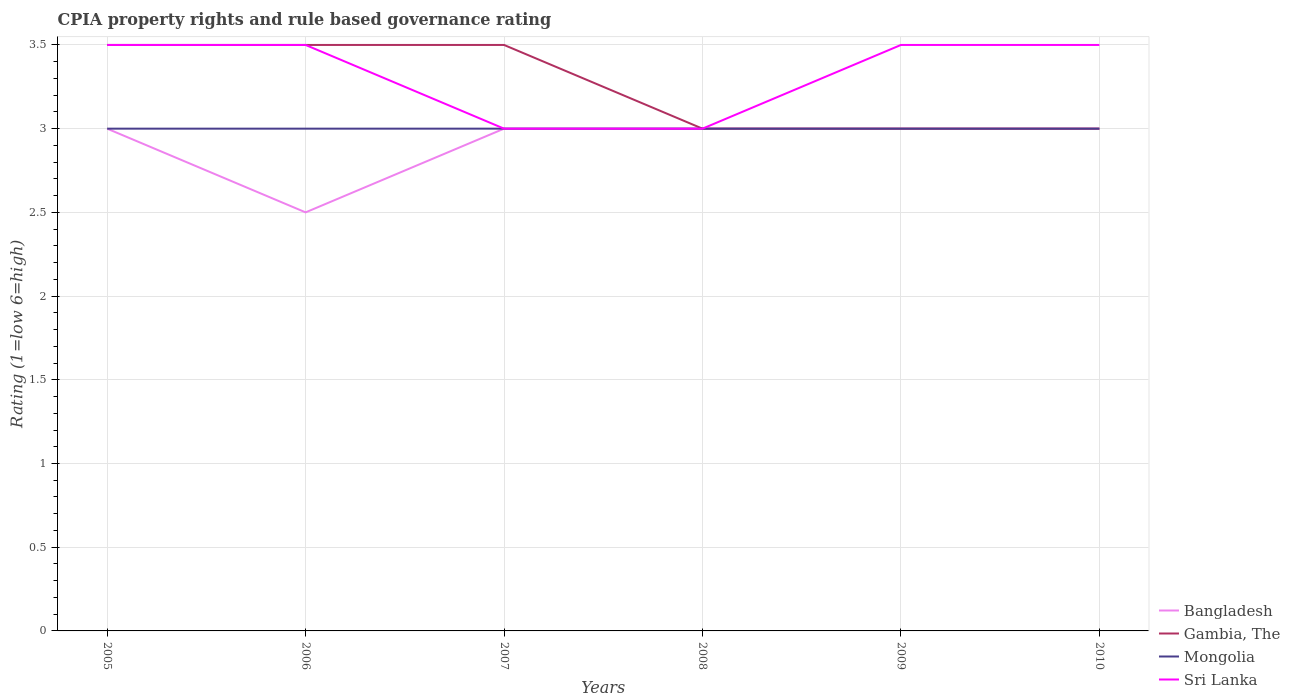Does the line corresponding to Bangladesh intersect with the line corresponding to Mongolia?
Your response must be concise. Yes. Is the number of lines equal to the number of legend labels?
Offer a very short reply. Yes. What is the difference between the highest and the lowest CPIA rating in Mongolia?
Make the answer very short. 0. How many lines are there?
Your response must be concise. 4. How many years are there in the graph?
Offer a terse response. 6. What is the difference between two consecutive major ticks on the Y-axis?
Offer a very short reply. 0.5. Are the values on the major ticks of Y-axis written in scientific E-notation?
Make the answer very short. No. Does the graph contain grids?
Offer a very short reply. Yes. Where does the legend appear in the graph?
Ensure brevity in your answer.  Bottom right. What is the title of the graph?
Your response must be concise. CPIA property rights and rule based governance rating. What is the label or title of the X-axis?
Ensure brevity in your answer.  Years. What is the Rating (1=low 6=high) of Bangladesh in 2006?
Give a very brief answer. 2.5. What is the Rating (1=low 6=high) of Sri Lanka in 2006?
Make the answer very short. 3.5. What is the Rating (1=low 6=high) in Mongolia in 2007?
Provide a succinct answer. 3. What is the Rating (1=low 6=high) of Gambia, The in 2008?
Your answer should be compact. 3. What is the Rating (1=low 6=high) of Mongolia in 2008?
Your answer should be compact. 3. What is the Rating (1=low 6=high) of Sri Lanka in 2008?
Make the answer very short. 3. What is the Rating (1=low 6=high) of Gambia, The in 2009?
Provide a short and direct response. 3. What is the Rating (1=low 6=high) in Mongolia in 2009?
Provide a succinct answer. 3. What is the Rating (1=low 6=high) of Sri Lanka in 2009?
Give a very brief answer. 3.5. What is the Rating (1=low 6=high) in Bangladesh in 2010?
Your answer should be very brief. 3. What is the Rating (1=low 6=high) of Mongolia in 2010?
Offer a very short reply. 3. Across all years, what is the maximum Rating (1=low 6=high) of Sri Lanka?
Your answer should be compact. 3.5. Across all years, what is the minimum Rating (1=low 6=high) of Bangladesh?
Ensure brevity in your answer.  2.5. Across all years, what is the minimum Rating (1=low 6=high) of Gambia, The?
Keep it short and to the point. 3. What is the difference between the Rating (1=low 6=high) of Gambia, The in 2005 and that in 2006?
Offer a terse response. 0. What is the difference between the Rating (1=low 6=high) in Sri Lanka in 2005 and that in 2006?
Provide a short and direct response. 0. What is the difference between the Rating (1=low 6=high) in Bangladesh in 2005 and that in 2007?
Ensure brevity in your answer.  0. What is the difference between the Rating (1=low 6=high) of Mongolia in 2005 and that in 2008?
Your response must be concise. 0. What is the difference between the Rating (1=low 6=high) of Gambia, The in 2005 and that in 2009?
Your answer should be very brief. 0.5. What is the difference between the Rating (1=low 6=high) of Mongolia in 2005 and that in 2009?
Offer a terse response. 0. What is the difference between the Rating (1=low 6=high) of Bangladesh in 2005 and that in 2010?
Offer a terse response. 0. What is the difference between the Rating (1=low 6=high) of Gambia, The in 2005 and that in 2010?
Your response must be concise. 0.5. What is the difference between the Rating (1=low 6=high) of Mongolia in 2005 and that in 2010?
Keep it short and to the point. 0. What is the difference between the Rating (1=low 6=high) of Bangladesh in 2006 and that in 2007?
Give a very brief answer. -0.5. What is the difference between the Rating (1=low 6=high) in Gambia, The in 2006 and that in 2007?
Offer a terse response. 0. What is the difference between the Rating (1=low 6=high) in Mongolia in 2006 and that in 2007?
Offer a terse response. 0. What is the difference between the Rating (1=low 6=high) in Gambia, The in 2006 and that in 2009?
Give a very brief answer. 0.5. What is the difference between the Rating (1=low 6=high) of Mongolia in 2006 and that in 2009?
Your answer should be very brief. 0. What is the difference between the Rating (1=low 6=high) of Sri Lanka in 2006 and that in 2009?
Give a very brief answer. 0. What is the difference between the Rating (1=low 6=high) of Sri Lanka in 2006 and that in 2010?
Your answer should be compact. 0. What is the difference between the Rating (1=low 6=high) of Bangladesh in 2007 and that in 2008?
Your answer should be compact. 0. What is the difference between the Rating (1=low 6=high) in Gambia, The in 2007 and that in 2008?
Give a very brief answer. 0.5. What is the difference between the Rating (1=low 6=high) of Mongolia in 2007 and that in 2008?
Provide a short and direct response. 0. What is the difference between the Rating (1=low 6=high) in Sri Lanka in 2007 and that in 2008?
Your response must be concise. 0. What is the difference between the Rating (1=low 6=high) in Mongolia in 2007 and that in 2010?
Your answer should be very brief. 0. What is the difference between the Rating (1=low 6=high) of Bangladesh in 2008 and that in 2009?
Keep it short and to the point. 0. What is the difference between the Rating (1=low 6=high) of Gambia, The in 2008 and that in 2009?
Keep it short and to the point. 0. What is the difference between the Rating (1=low 6=high) in Sri Lanka in 2008 and that in 2009?
Provide a succinct answer. -0.5. What is the difference between the Rating (1=low 6=high) of Mongolia in 2008 and that in 2010?
Provide a succinct answer. 0. What is the difference between the Rating (1=low 6=high) of Bangladesh in 2005 and the Rating (1=low 6=high) of Mongolia in 2006?
Ensure brevity in your answer.  0. What is the difference between the Rating (1=low 6=high) in Bangladesh in 2005 and the Rating (1=low 6=high) in Sri Lanka in 2006?
Provide a succinct answer. -0.5. What is the difference between the Rating (1=low 6=high) in Gambia, The in 2005 and the Rating (1=low 6=high) in Sri Lanka in 2006?
Your response must be concise. 0. What is the difference between the Rating (1=low 6=high) of Mongolia in 2005 and the Rating (1=low 6=high) of Sri Lanka in 2006?
Your answer should be compact. -0.5. What is the difference between the Rating (1=low 6=high) of Bangladesh in 2005 and the Rating (1=low 6=high) of Gambia, The in 2007?
Make the answer very short. -0.5. What is the difference between the Rating (1=low 6=high) in Bangladesh in 2005 and the Rating (1=low 6=high) in Mongolia in 2007?
Provide a short and direct response. 0. What is the difference between the Rating (1=low 6=high) of Bangladesh in 2005 and the Rating (1=low 6=high) of Sri Lanka in 2007?
Your answer should be very brief. 0. What is the difference between the Rating (1=low 6=high) of Gambia, The in 2005 and the Rating (1=low 6=high) of Sri Lanka in 2007?
Your answer should be compact. 0.5. What is the difference between the Rating (1=low 6=high) of Bangladesh in 2005 and the Rating (1=low 6=high) of Sri Lanka in 2008?
Provide a short and direct response. 0. What is the difference between the Rating (1=low 6=high) of Gambia, The in 2005 and the Rating (1=low 6=high) of Sri Lanka in 2008?
Provide a succinct answer. 0.5. What is the difference between the Rating (1=low 6=high) of Bangladesh in 2005 and the Rating (1=low 6=high) of Gambia, The in 2009?
Your response must be concise. 0. What is the difference between the Rating (1=low 6=high) in Bangladesh in 2005 and the Rating (1=low 6=high) in Sri Lanka in 2009?
Provide a succinct answer. -0.5. What is the difference between the Rating (1=low 6=high) in Gambia, The in 2005 and the Rating (1=low 6=high) in Mongolia in 2009?
Ensure brevity in your answer.  0.5. What is the difference between the Rating (1=low 6=high) in Bangladesh in 2005 and the Rating (1=low 6=high) in Sri Lanka in 2010?
Offer a very short reply. -0.5. What is the difference between the Rating (1=low 6=high) of Gambia, The in 2005 and the Rating (1=low 6=high) of Sri Lanka in 2010?
Provide a succinct answer. 0. What is the difference between the Rating (1=low 6=high) in Mongolia in 2005 and the Rating (1=low 6=high) in Sri Lanka in 2010?
Your answer should be compact. -0.5. What is the difference between the Rating (1=low 6=high) in Bangladesh in 2006 and the Rating (1=low 6=high) in Sri Lanka in 2007?
Your answer should be very brief. -0.5. What is the difference between the Rating (1=low 6=high) of Gambia, The in 2006 and the Rating (1=low 6=high) of Sri Lanka in 2007?
Offer a terse response. 0.5. What is the difference between the Rating (1=low 6=high) of Bangladesh in 2006 and the Rating (1=low 6=high) of Gambia, The in 2008?
Make the answer very short. -0.5. What is the difference between the Rating (1=low 6=high) in Bangladesh in 2006 and the Rating (1=low 6=high) in Sri Lanka in 2008?
Your answer should be compact. -0.5. What is the difference between the Rating (1=low 6=high) of Gambia, The in 2006 and the Rating (1=low 6=high) of Sri Lanka in 2008?
Keep it short and to the point. 0.5. What is the difference between the Rating (1=low 6=high) of Gambia, The in 2006 and the Rating (1=low 6=high) of Sri Lanka in 2009?
Offer a very short reply. 0. What is the difference between the Rating (1=low 6=high) of Mongolia in 2006 and the Rating (1=low 6=high) of Sri Lanka in 2009?
Ensure brevity in your answer.  -0.5. What is the difference between the Rating (1=low 6=high) in Bangladesh in 2006 and the Rating (1=low 6=high) in Gambia, The in 2010?
Make the answer very short. -0.5. What is the difference between the Rating (1=low 6=high) in Bangladesh in 2006 and the Rating (1=low 6=high) in Mongolia in 2010?
Your response must be concise. -0.5. What is the difference between the Rating (1=low 6=high) in Gambia, The in 2006 and the Rating (1=low 6=high) in Mongolia in 2010?
Ensure brevity in your answer.  0.5. What is the difference between the Rating (1=low 6=high) of Mongolia in 2006 and the Rating (1=low 6=high) of Sri Lanka in 2010?
Ensure brevity in your answer.  -0.5. What is the difference between the Rating (1=low 6=high) in Bangladesh in 2007 and the Rating (1=low 6=high) in Mongolia in 2008?
Make the answer very short. 0. What is the difference between the Rating (1=low 6=high) of Gambia, The in 2007 and the Rating (1=low 6=high) of Mongolia in 2008?
Offer a terse response. 0.5. What is the difference between the Rating (1=low 6=high) in Mongolia in 2007 and the Rating (1=low 6=high) in Sri Lanka in 2008?
Ensure brevity in your answer.  0. What is the difference between the Rating (1=low 6=high) of Bangladesh in 2007 and the Rating (1=low 6=high) of Gambia, The in 2009?
Keep it short and to the point. 0. What is the difference between the Rating (1=low 6=high) in Bangladesh in 2007 and the Rating (1=low 6=high) in Sri Lanka in 2009?
Give a very brief answer. -0.5. What is the difference between the Rating (1=low 6=high) in Gambia, The in 2007 and the Rating (1=low 6=high) in Mongolia in 2009?
Keep it short and to the point. 0.5. What is the difference between the Rating (1=low 6=high) in Bangladesh in 2007 and the Rating (1=low 6=high) in Sri Lanka in 2010?
Your response must be concise. -0.5. What is the difference between the Rating (1=low 6=high) of Gambia, The in 2008 and the Rating (1=low 6=high) of Mongolia in 2009?
Provide a succinct answer. 0. What is the difference between the Rating (1=low 6=high) of Bangladesh in 2008 and the Rating (1=low 6=high) of Gambia, The in 2010?
Keep it short and to the point. 0. What is the difference between the Rating (1=low 6=high) in Gambia, The in 2008 and the Rating (1=low 6=high) in Sri Lanka in 2010?
Your response must be concise. -0.5. What is the difference between the Rating (1=low 6=high) in Bangladesh in 2009 and the Rating (1=low 6=high) in Gambia, The in 2010?
Provide a succinct answer. 0. What is the difference between the Rating (1=low 6=high) in Bangladesh in 2009 and the Rating (1=low 6=high) in Mongolia in 2010?
Your answer should be compact. 0. What is the difference between the Rating (1=low 6=high) in Bangladesh in 2009 and the Rating (1=low 6=high) in Sri Lanka in 2010?
Make the answer very short. -0.5. What is the difference between the Rating (1=low 6=high) in Gambia, The in 2009 and the Rating (1=low 6=high) in Mongolia in 2010?
Provide a short and direct response. 0. What is the difference between the Rating (1=low 6=high) of Gambia, The in 2009 and the Rating (1=low 6=high) of Sri Lanka in 2010?
Provide a short and direct response. -0.5. What is the average Rating (1=low 6=high) in Bangladesh per year?
Your answer should be compact. 2.92. What is the average Rating (1=low 6=high) in Gambia, The per year?
Keep it short and to the point. 3.25. In the year 2005, what is the difference between the Rating (1=low 6=high) of Bangladesh and Rating (1=low 6=high) of Mongolia?
Provide a short and direct response. 0. In the year 2005, what is the difference between the Rating (1=low 6=high) of Gambia, The and Rating (1=low 6=high) of Mongolia?
Provide a short and direct response. 0.5. In the year 2005, what is the difference between the Rating (1=low 6=high) of Gambia, The and Rating (1=low 6=high) of Sri Lanka?
Provide a short and direct response. 0. In the year 2006, what is the difference between the Rating (1=low 6=high) of Bangladesh and Rating (1=low 6=high) of Gambia, The?
Provide a short and direct response. -1. In the year 2006, what is the difference between the Rating (1=low 6=high) of Bangladesh and Rating (1=low 6=high) of Sri Lanka?
Provide a succinct answer. -1. In the year 2006, what is the difference between the Rating (1=low 6=high) in Gambia, The and Rating (1=low 6=high) in Mongolia?
Make the answer very short. 0.5. In the year 2006, what is the difference between the Rating (1=low 6=high) in Gambia, The and Rating (1=low 6=high) in Sri Lanka?
Your answer should be very brief. 0. In the year 2007, what is the difference between the Rating (1=low 6=high) of Bangladesh and Rating (1=low 6=high) of Mongolia?
Provide a short and direct response. 0. In the year 2007, what is the difference between the Rating (1=low 6=high) in Bangladesh and Rating (1=low 6=high) in Sri Lanka?
Ensure brevity in your answer.  0. In the year 2007, what is the difference between the Rating (1=low 6=high) of Gambia, The and Rating (1=low 6=high) of Mongolia?
Give a very brief answer. 0.5. In the year 2008, what is the difference between the Rating (1=low 6=high) of Bangladesh and Rating (1=low 6=high) of Sri Lanka?
Offer a very short reply. 0. In the year 2008, what is the difference between the Rating (1=low 6=high) of Gambia, The and Rating (1=low 6=high) of Mongolia?
Offer a terse response. 0. In the year 2008, what is the difference between the Rating (1=low 6=high) in Mongolia and Rating (1=low 6=high) in Sri Lanka?
Ensure brevity in your answer.  0. In the year 2009, what is the difference between the Rating (1=low 6=high) in Bangladesh and Rating (1=low 6=high) in Gambia, The?
Provide a short and direct response. 0. In the year 2010, what is the difference between the Rating (1=low 6=high) of Gambia, The and Rating (1=low 6=high) of Mongolia?
Keep it short and to the point. 0. In the year 2010, what is the difference between the Rating (1=low 6=high) of Gambia, The and Rating (1=low 6=high) of Sri Lanka?
Your answer should be compact. -0.5. What is the ratio of the Rating (1=low 6=high) in Bangladesh in 2005 to that in 2006?
Ensure brevity in your answer.  1.2. What is the ratio of the Rating (1=low 6=high) of Gambia, The in 2005 to that in 2007?
Your answer should be very brief. 1. What is the ratio of the Rating (1=low 6=high) in Mongolia in 2005 to that in 2007?
Your answer should be very brief. 1. What is the ratio of the Rating (1=low 6=high) of Sri Lanka in 2005 to that in 2007?
Offer a terse response. 1.17. What is the ratio of the Rating (1=low 6=high) in Bangladesh in 2005 to that in 2008?
Your answer should be compact. 1. What is the ratio of the Rating (1=low 6=high) in Mongolia in 2005 to that in 2008?
Make the answer very short. 1. What is the ratio of the Rating (1=low 6=high) in Bangladesh in 2005 to that in 2009?
Make the answer very short. 1. What is the ratio of the Rating (1=low 6=high) in Gambia, The in 2005 to that in 2009?
Ensure brevity in your answer.  1.17. What is the ratio of the Rating (1=low 6=high) in Bangladesh in 2005 to that in 2010?
Your answer should be very brief. 1. What is the ratio of the Rating (1=low 6=high) in Gambia, The in 2005 to that in 2010?
Provide a succinct answer. 1.17. What is the ratio of the Rating (1=low 6=high) of Gambia, The in 2006 to that in 2007?
Your answer should be very brief. 1. What is the ratio of the Rating (1=low 6=high) of Mongolia in 2006 to that in 2008?
Your answer should be very brief. 1. What is the ratio of the Rating (1=low 6=high) in Bangladesh in 2006 to that in 2010?
Offer a terse response. 0.83. What is the ratio of the Rating (1=low 6=high) of Bangladesh in 2007 to that in 2008?
Your answer should be compact. 1. What is the ratio of the Rating (1=low 6=high) in Gambia, The in 2007 to that in 2008?
Offer a very short reply. 1.17. What is the ratio of the Rating (1=low 6=high) of Mongolia in 2007 to that in 2008?
Offer a very short reply. 1. What is the ratio of the Rating (1=low 6=high) of Sri Lanka in 2007 to that in 2008?
Your response must be concise. 1. What is the ratio of the Rating (1=low 6=high) in Mongolia in 2007 to that in 2009?
Provide a short and direct response. 1. What is the ratio of the Rating (1=low 6=high) in Sri Lanka in 2007 to that in 2009?
Provide a short and direct response. 0.86. What is the ratio of the Rating (1=low 6=high) of Bangladesh in 2007 to that in 2010?
Keep it short and to the point. 1. What is the ratio of the Rating (1=low 6=high) in Mongolia in 2007 to that in 2010?
Your response must be concise. 1. What is the ratio of the Rating (1=low 6=high) in Sri Lanka in 2007 to that in 2010?
Your response must be concise. 0.86. What is the ratio of the Rating (1=low 6=high) in Bangladesh in 2008 to that in 2009?
Your answer should be very brief. 1. What is the ratio of the Rating (1=low 6=high) of Gambia, The in 2008 to that in 2010?
Keep it short and to the point. 1. What is the ratio of the Rating (1=low 6=high) in Mongolia in 2008 to that in 2010?
Offer a very short reply. 1. What is the ratio of the Rating (1=low 6=high) of Sri Lanka in 2008 to that in 2010?
Your answer should be very brief. 0.86. What is the ratio of the Rating (1=low 6=high) in Bangladesh in 2009 to that in 2010?
Your response must be concise. 1. What is the ratio of the Rating (1=low 6=high) of Gambia, The in 2009 to that in 2010?
Your answer should be very brief. 1. What is the ratio of the Rating (1=low 6=high) of Mongolia in 2009 to that in 2010?
Make the answer very short. 1. What is the ratio of the Rating (1=low 6=high) of Sri Lanka in 2009 to that in 2010?
Make the answer very short. 1. What is the difference between the highest and the second highest Rating (1=low 6=high) of Bangladesh?
Offer a very short reply. 0. What is the difference between the highest and the second highest Rating (1=low 6=high) of Gambia, The?
Provide a succinct answer. 0. What is the difference between the highest and the second highest Rating (1=low 6=high) in Mongolia?
Make the answer very short. 0. What is the difference between the highest and the lowest Rating (1=low 6=high) in Mongolia?
Make the answer very short. 0. What is the difference between the highest and the lowest Rating (1=low 6=high) of Sri Lanka?
Offer a very short reply. 0.5. 